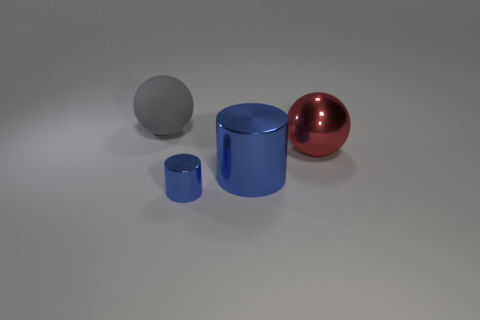What number of cubes are cyan metal objects or large metal things?
Keep it short and to the point. 0. There is another thing that is the same color as the small metallic thing; what material is it?
Make the answer very short. Metal. There is a small metal thing; is its color the same as the cylinder that is behind the small blue cylinder?
Your answer should be compact. Yes. The tiny object is what color?
Provide a succinct answer. Blue. How many things are big blue metal objects or yellow cylinders?
Give a very brief answer. 1. There is a gray sphere that is the same size as the red ball; what is its material?
Provide a succinct answer. Rubber. What size is the metallic cylinder left of the big shiny cylinder?
Your answer should be very brief. Small. What is the material of the big gray sphere?
Make the answer very short. Rubber. How many objects are either blue cylinders that are right of the small blue cylinder or large objects in front of the big red sphere?
Ensure brevity in your answer.  1. How many other objects are the same color as the small shiny cylinder?
Provide a succinct answer. 1. 